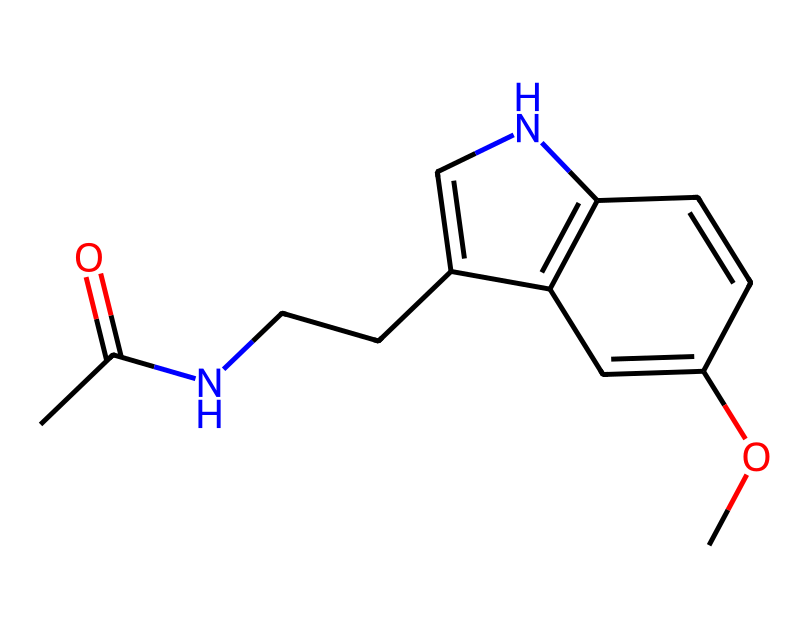how many carbon atoms are in this compound? By analyzing the SMILES representation of the chemical, I can identify all the carbon (C) atoms present. In total, there are 12 carbon atoms represented in the structure.
Answer: 12 what is the name of this chemical? Based on the provided SMILES structure, this compound is identified as melatonin, which is known for its role in regulating sleep.
Answer: melatonin how many double bonds are present in the structure? In the SMILES, I check for any occurrences of "=" which indicates a double bond. There are 4 double bonds visible in the structure of melatonin.
Answer: 4 is there a nitrogen atom in this molecule? Looking through the SMILES notation, I can locate the presence of nitrogen (N) atoms, and there is one nitrogen atom in this structure.
Answer: yes what functional group is present in melatonin that is associated with sleep regulation? In analyzing the structure, I find that melatonin contains an indole functional group, which is crucial for its biological activity related to sleep.
Answer: indole what is the total number of heteroatoms in melatonin? I first identify the heteroatoms, which are atoms in the compound that are not carbon or hydrogen. In the case of melatonin, the heteroatoms include one nitrogen and three oxygen atoms, making a total of four.
Answer: 4 what property of melatonin makes it effective as a sleep aid? Analyzing the structure, I see that melatonin’s ability to mimic the natural hormone levels in our body helps regulate our sleep-wake cycle effectively.
Answer: mimicry of natural hormones 